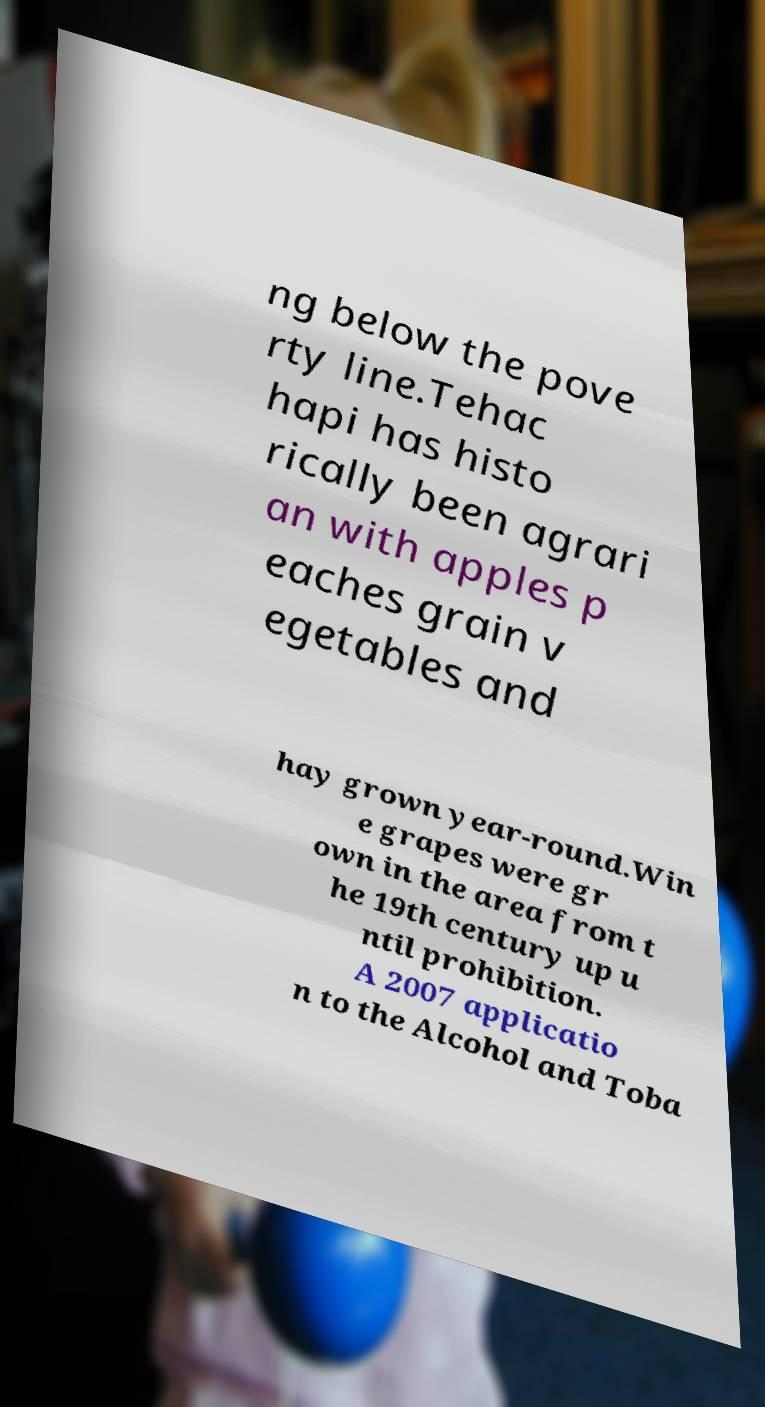Can you read and provide the text displayed in the image?This photo seems to have some interesting text. Can you extract and type it out for me? ng below the pove rty line.Tehac hapi has histo rically been agrari an with apples p eaches grain v egetables and hay grown year-round.Win e grapes were gr own in the area from t he 19th century up u ntil prohibition. A 2007 applicatio n to the Alcohol and Toba 